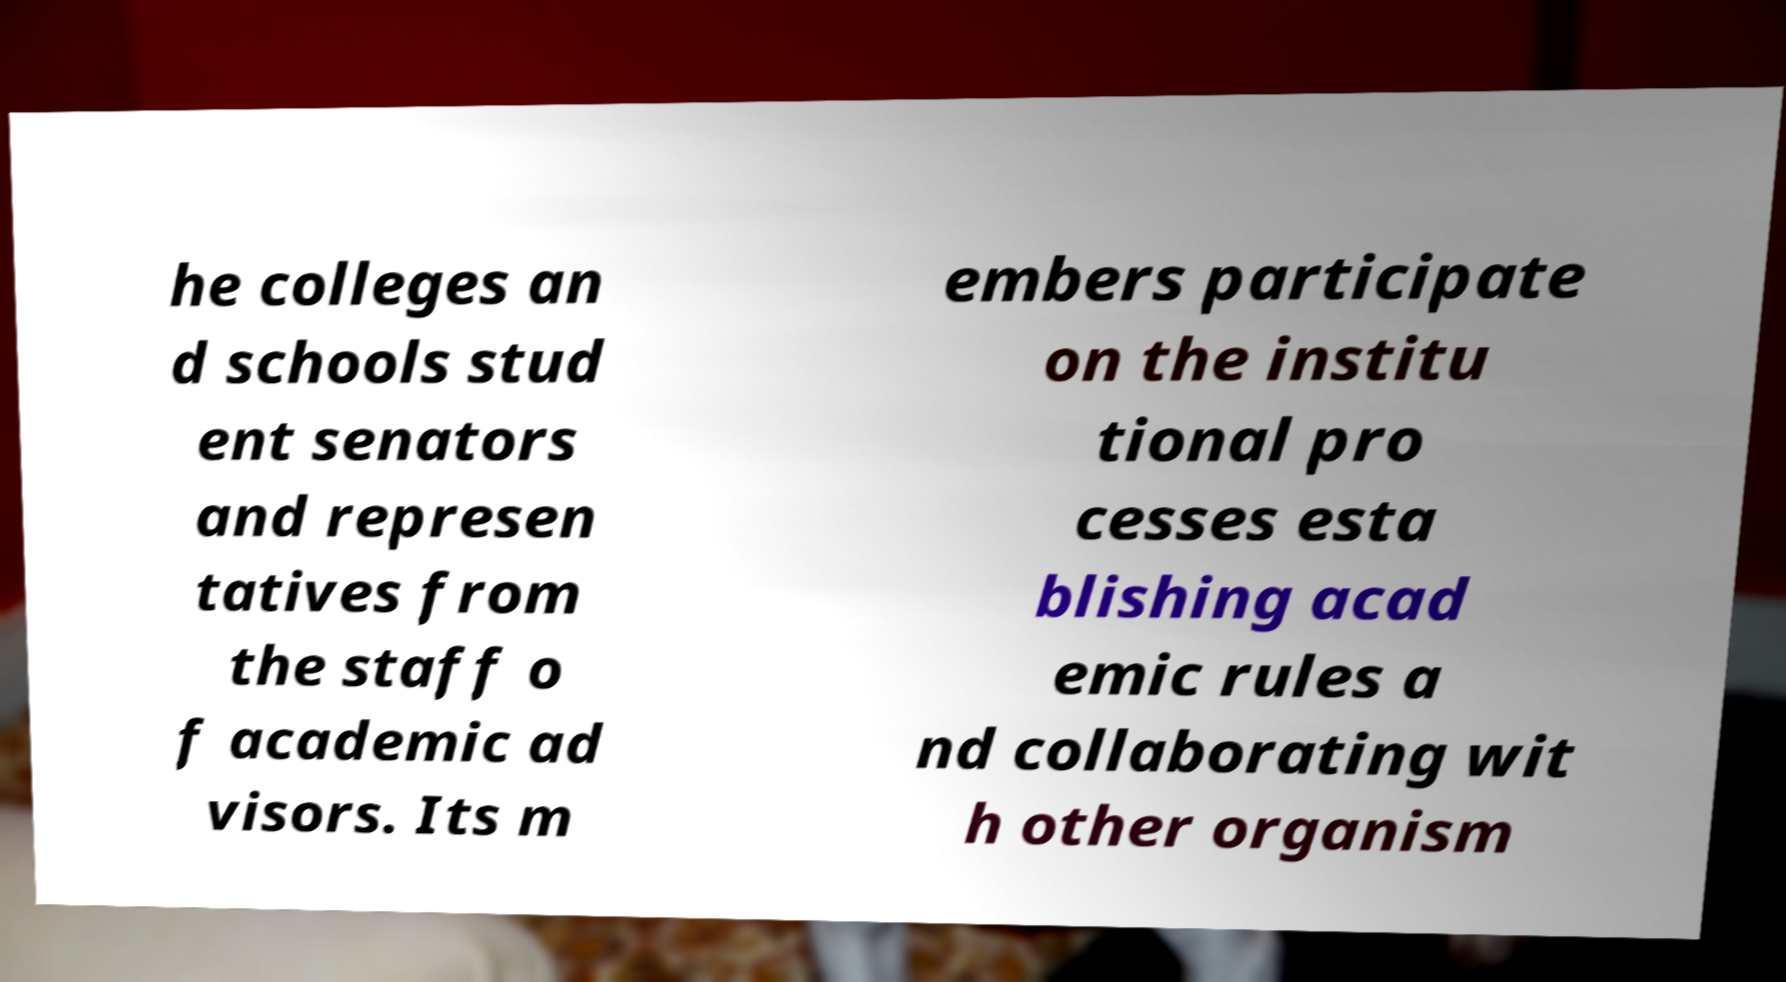Could you assist in decoding the text presented in this image and type it out clearly? he colleges an d schools stud ent senators and represen tatives from the staff o f academic ad visors. Its m embers participate on the institu tional pro cesses esta blishing acad emic rules a nd collaborating wit h other organism 